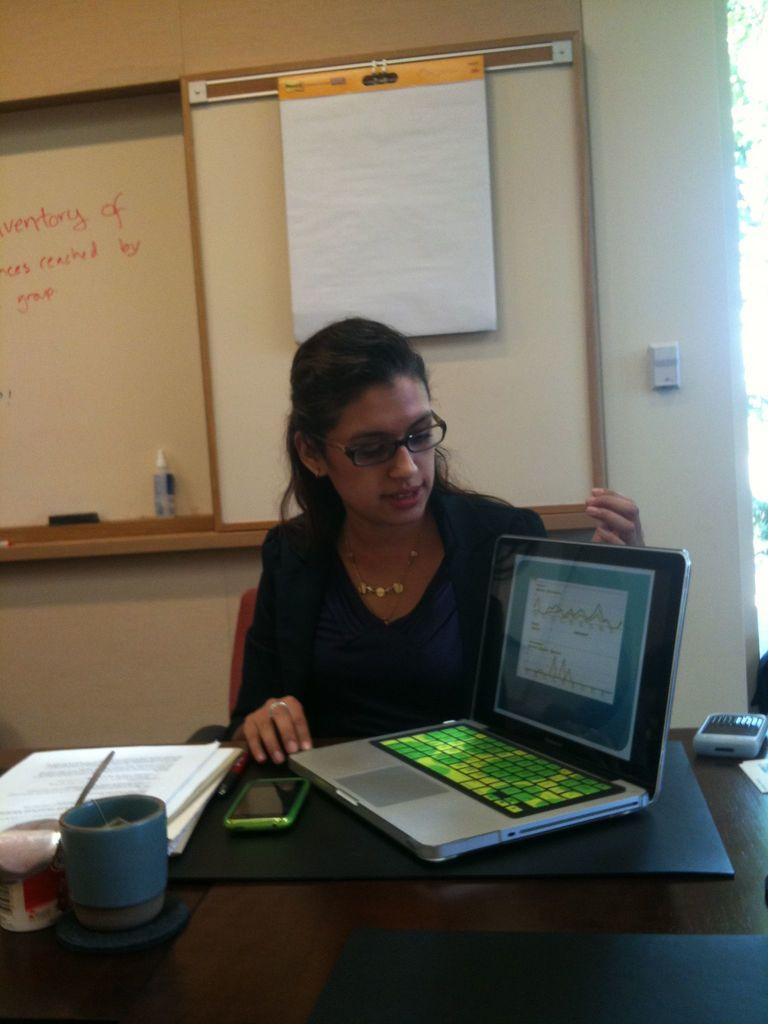What is the person in the image doing? The person is sitting in front of a table. What objects can be seen on the table? There is a laptop, a mobile, and books on the table. Is there anything hanging on the wall in the background? Yes, there is a paper hung on the wall in the background. What type of humor can be seen in the image? There is no humor present in the image; it is a person sitting in front of a table with various objects. What direction is the person facing in the image? The image does not provide enough information to determine the direction the person is facing. 